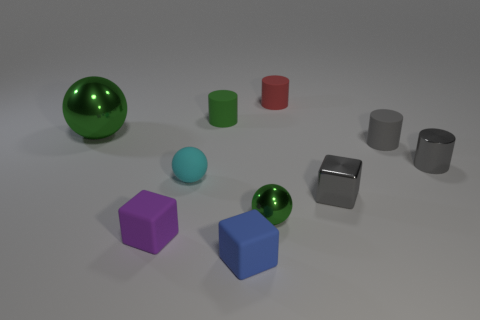Subtract all blocks. How many objects are left? 7 Add 7 small purple matte blocks. How many small purple matte blocks are left? 8 Add 3 cyan rubber objects. How many cyan rubber objects exist? 4 Subtract 0 brown spheres. How many objects are left? 10 Subtract all cyan matte things. Subtract all green matte objects. How many objects are left? 8 